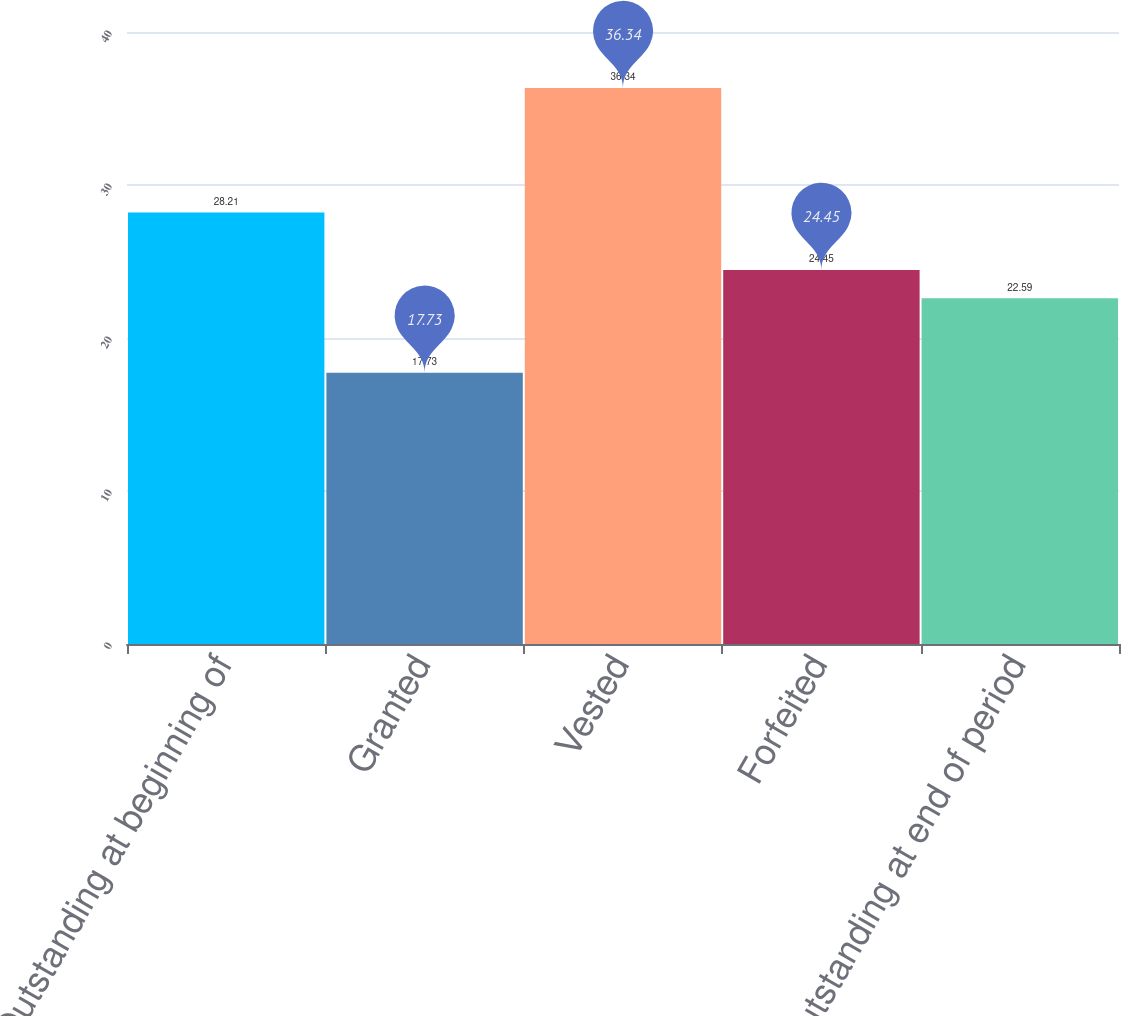Convert chart to OTSL. <chart><loc_0><loc_0><loc_500><loc_500><bar_chart><fcel>Outstanding at beginning of<fcel>Granted<fcel>Vested<fcel>Forfeited<fcel>Outstanding at end of period<nl><fcel>28.21<fcel>17.73<fcel>36.34<fcel>24.45<fcel>22.59<nl></chart> 